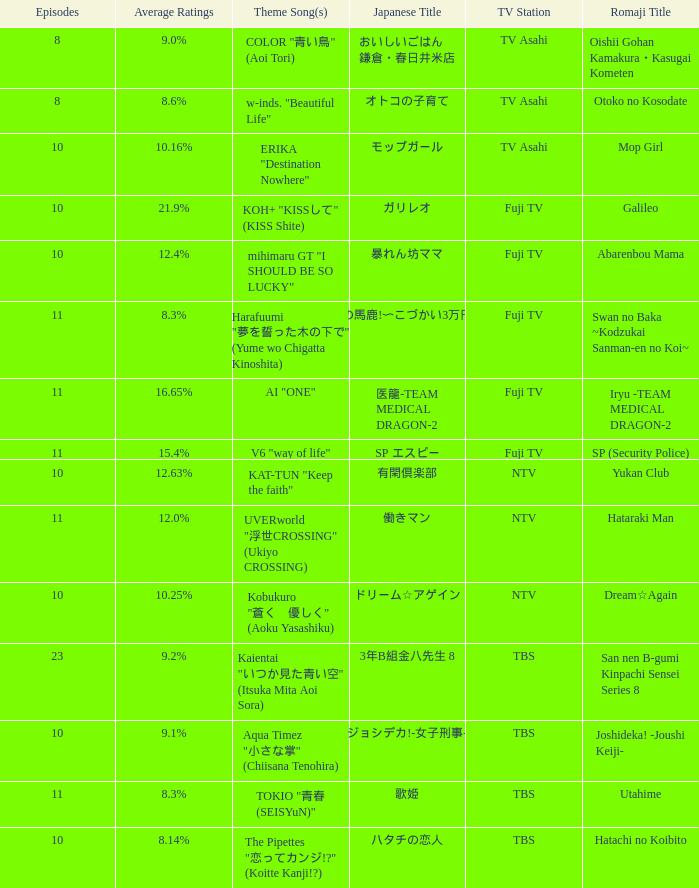Can you tell me the theme song for the yukan club? KAT-TUN "Keep the faith". 